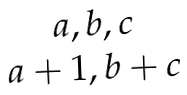Convert formula to latex. <formula><loc_0><loc_0><loc_500><loc_500>\begin{matrix} { a , b , c } \\ { a + 1 , b + c } \end{matrix}</formula> 